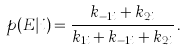<formula> <loc_0><loc_0><loc_500><loc_500>p ( E | i ) = \frac { k _ { - 1 i } + k _ { 2 i } } { k _ { 1 i } + k _ { - 1 i } + k _ { 2 i } } \, .</formula> 